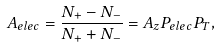Convert formula to latex. <formula><loc_0><loc_0><loc_500><loc_500>A _ { e l e c } = \frac { N _ { + } - N _ { - } } { N _ { + } + N _ { - } } = A _ { z } P _ { e l e c } P _ { T } ,</formula> 